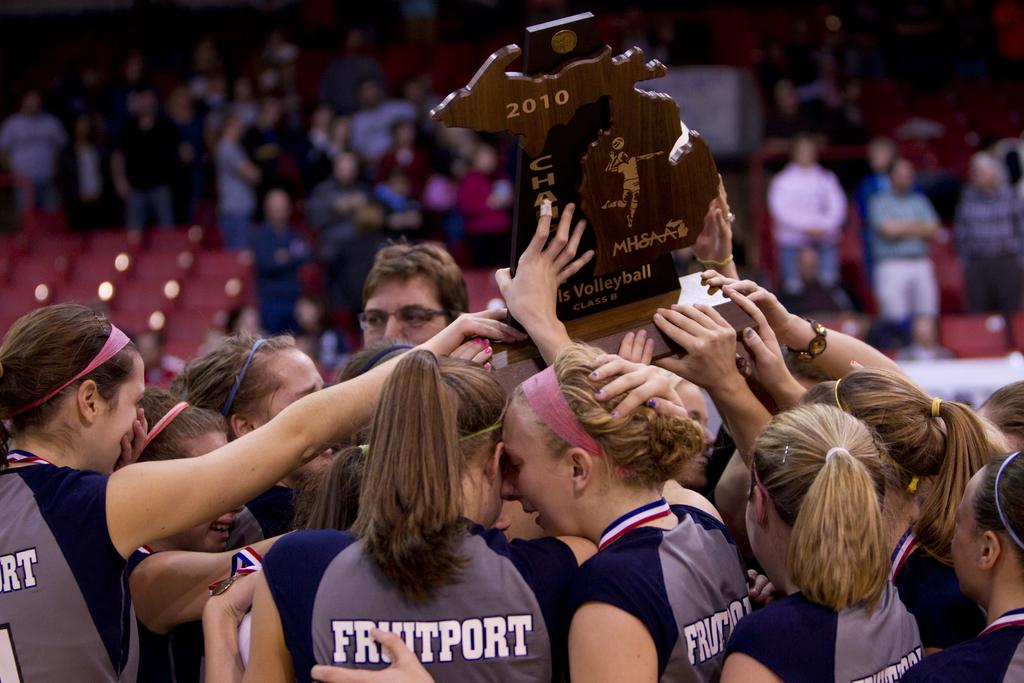<image>
Render a clear and concise summary of the photo. a few women huddling with the word fruitport on their backs 